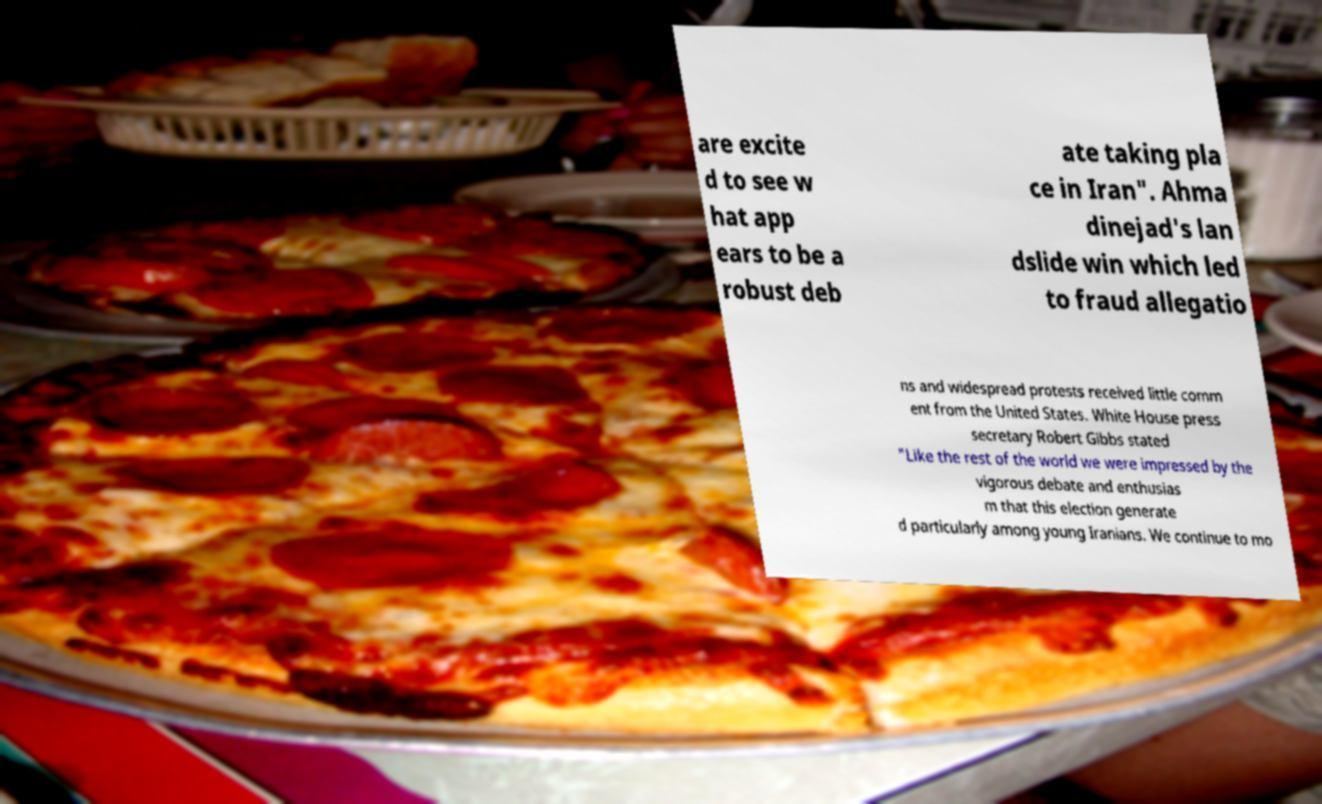Could you assist in decoding the text presented in this image and type it out clearly? are excite d to see w hat app ears to be a robust deb ate taking pla ce in Iran". Ahma dinejad's lan dslide win which led to fraud allegatio ns and widespread protests received little comm ent from the United States. White House press secretary Robert Gibbs stated "Like the rest of the world we were impressed by the vigorous debate and enthusias m that this election generate d particularly among young Iranians. We continue to mo 